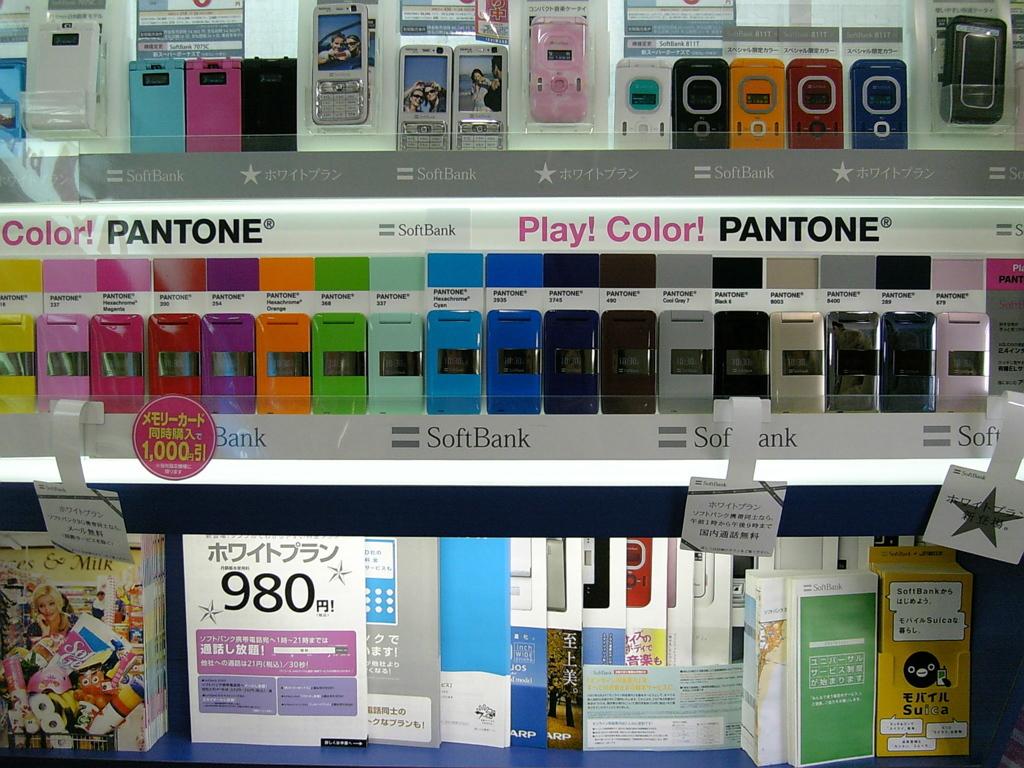What brand uses play! color! as part of their advertising campaign?
Offer a very short reply. Pantone. What's the number in the bottom left?
Offer a terse response. 980. 